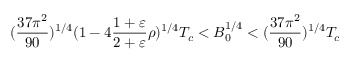Convert formula to latex. <formula><loc_0><loc_0><loc_500><loc_500>( { \frac { 3 7 \pi ^ { 2 } } { 9 0 } } ) ^ { 1 / 4 } ( 1 - 4 { \frac { 1 + \varepsilon } { 2 + \varepsilon } } \rho ) ^ { 1 / 4 } T _ { c } < B _ { 0 } ^ { 1 / 4 } < ( { \frac { 3 7 \pi ^ { 2 } } { 9 0 } } ) ^ { 1 / 4 } T _ { c }</formula> 